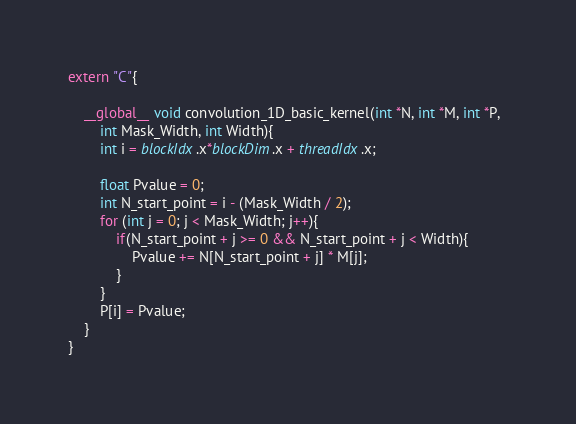Convert code to text. <code><loc_0><loc_0><loc_500><loc_500><_Cuda_>extern "C"{

    __global__ void convolution_1D_basic_kernel(int *N, int *M, int *P,  
        int Mask_Width, int Width){  
        int i = blockIdx.x*blockDim.x + threadIdx.x;  

        float Pvalue = 0;  
        int N_start_point = i - (Mask_Width / 2);  
        for (int j = 0; j < Mask_Width; j++){  
            if(N_start_point + j >= 0 && N_start_point + j < Width){  
                Pvalue += N[N_start_point + j] * M[j];  
            }  
        }  
        P[i] = Pvalue;  
    }
}</code> 